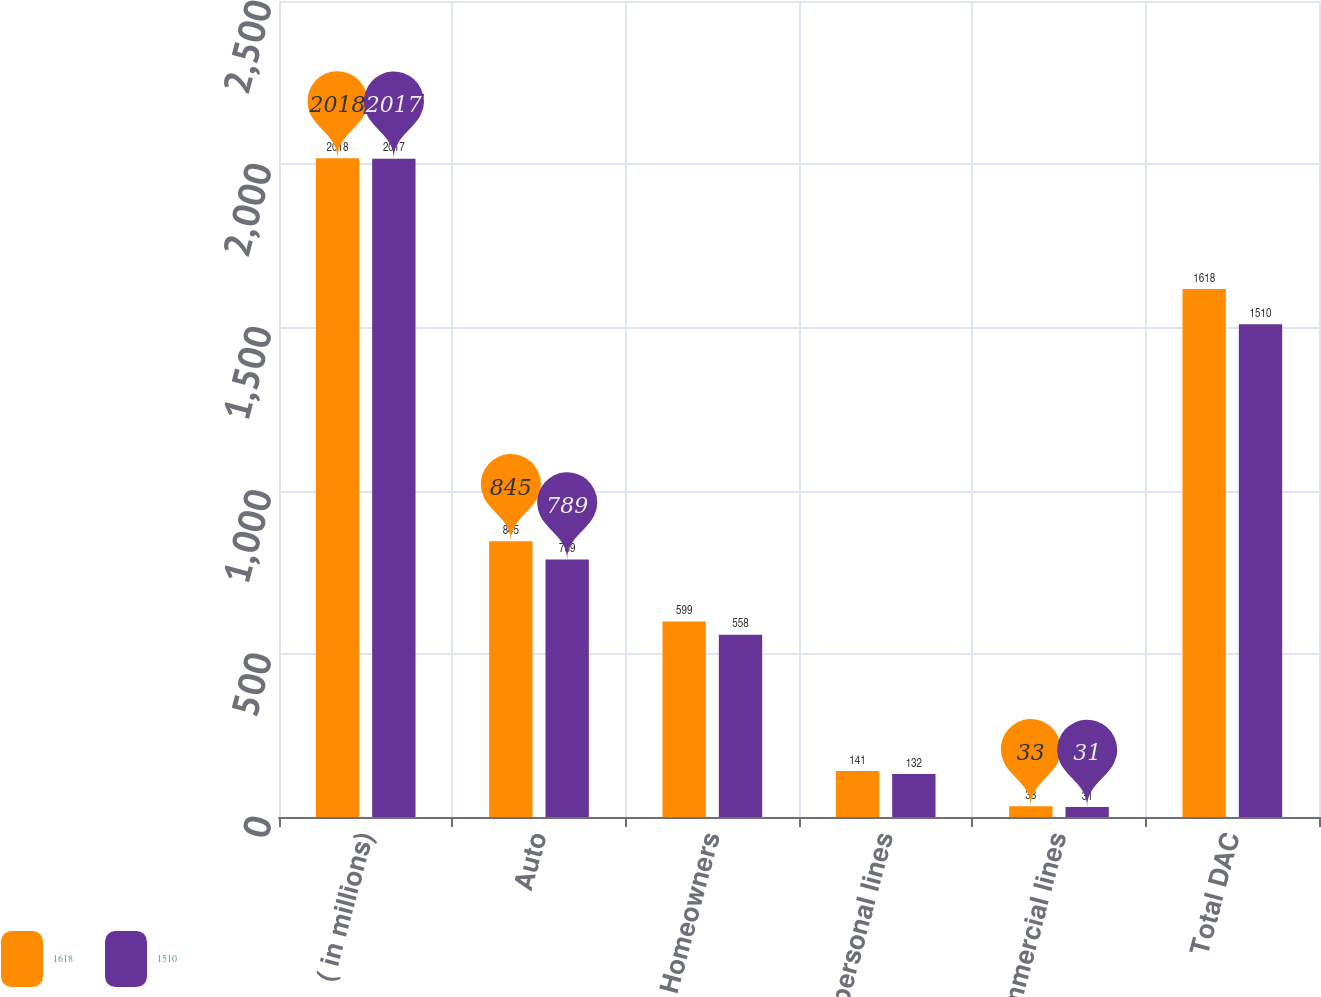Convert chart to OTSL. <chart><loc_0><loc_0><loc_500><loc_500><stacked_bar_chart><ecel><fcel>( in millions)<fcel>Auto<fcel>Homeowners<fcel>Other personal lines<fcel>Commercial lines<fcel>Total DAC<nl><fcel>1618<fcel>2018<fcel>845<fcel>599<fcel>141<fcel>33<fcel>1618<nl><fcel>1510<fcel>2017<fcel>789<fcel>558<fcel>132<fcel>31<fcel>1510<nl></chart> 